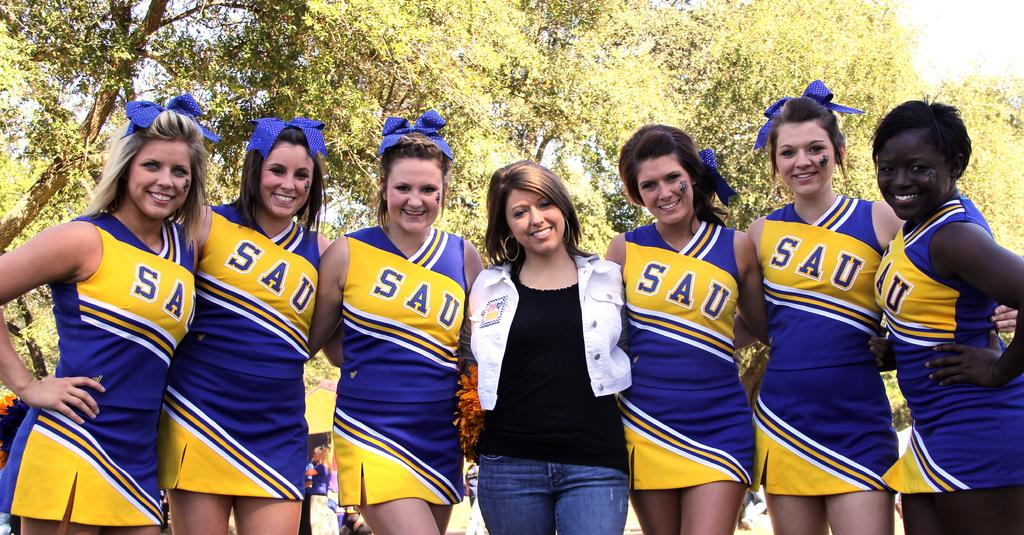<image>
Write a terse but informative summary of the picture. Cheerleaders for SAU embrace each other for a photo. 